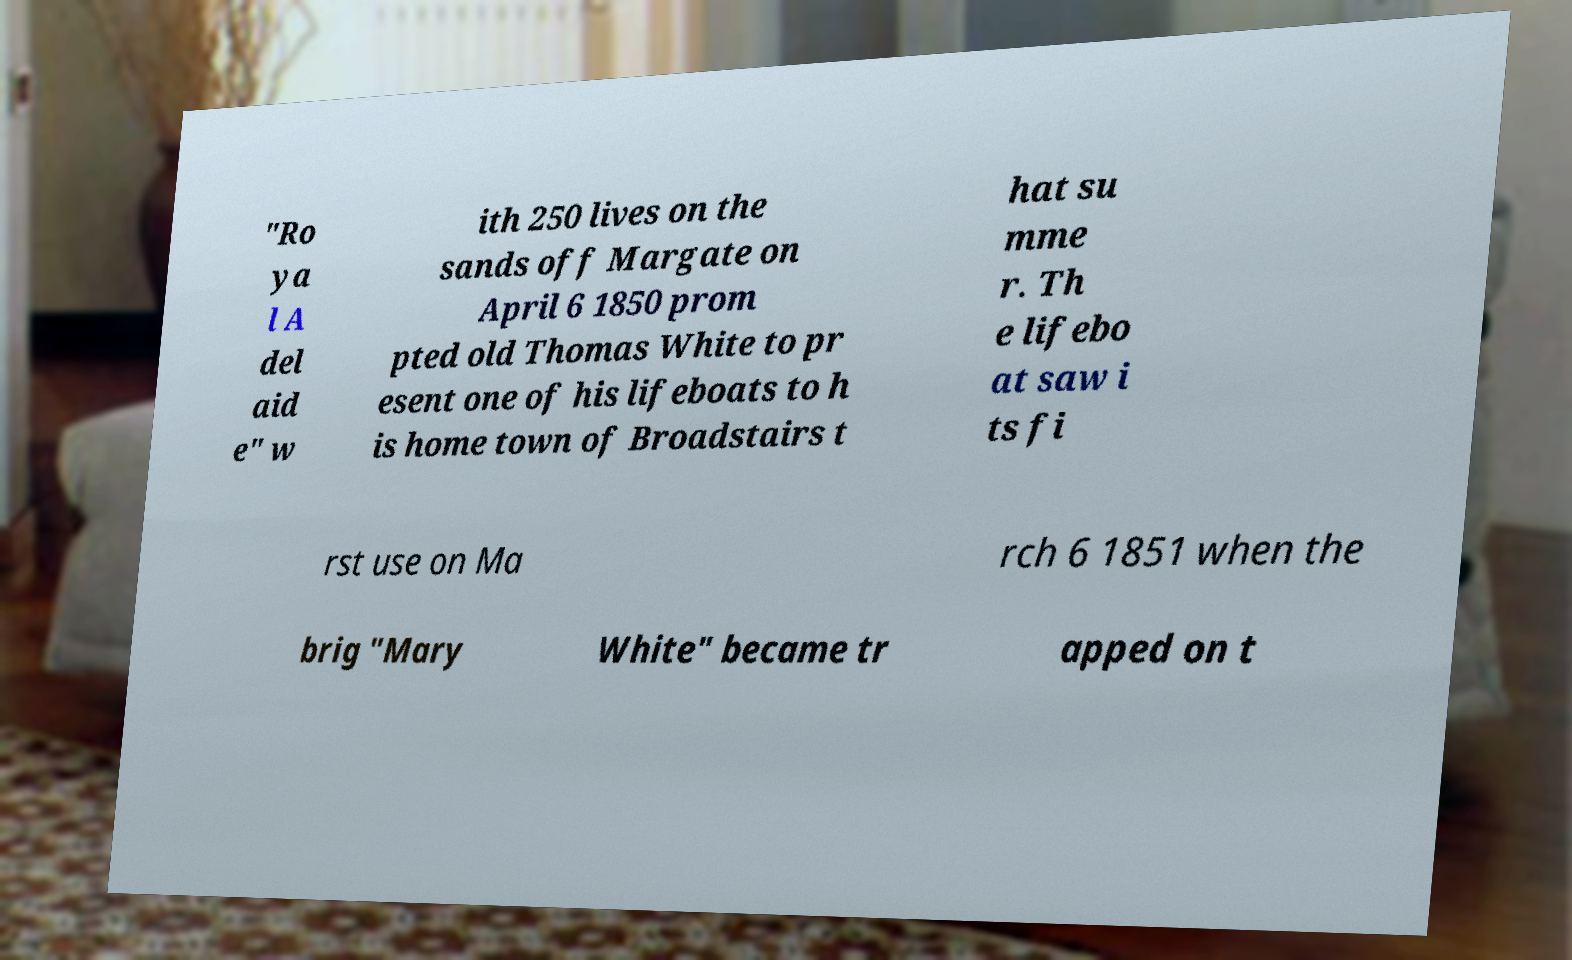There's text embedded in this image that I need extracted. Can you transcribe it verbatim? "Ro ya l A del aid e" w ith 250 lives on the sands off Margate on April 6 1850 prom pted old Thomas White to pr esent one of his lifeboats to h is home town of Broadstairs t hat su mme r. Th e lifebo at saw i ts fi rst use on Ma rch 6 1851 when the brig "Mary White" became tr apped on t 